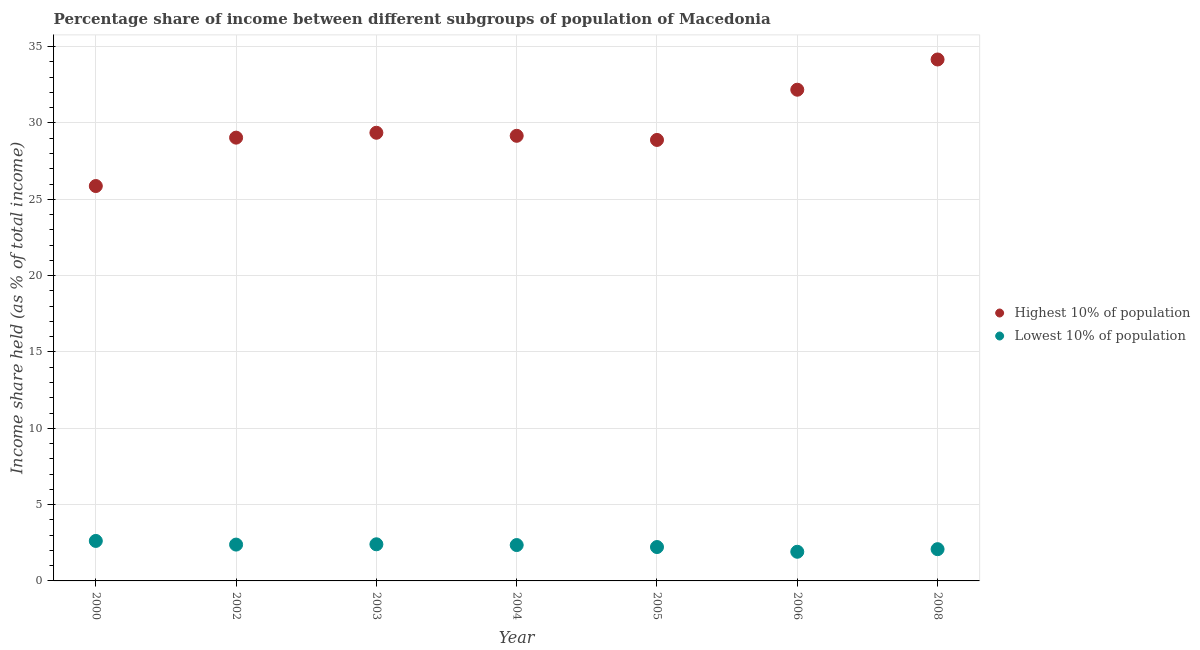How many different coloured dotlines are there?
Give a very brief answer. 2. What is the income share held by lowest 10% of the population in 2000?
Your answer should be compact. 2.62. Across all years, what is the maximum income share held by highest 10% of the population?
Your response must be concise. 34.16. Across all years, what is the minimum income share held by highest 10% of the population?
Ensure brevity in your answer.  25.87. In which year was the income share held by lowest 10% of the population maximum?
Your answer should be very brief. 2000. In which year was the income share held by highest 10% of the population minimum?
Your answer should be compact. 2000. What is the total income share held by highest 10% of the population in the graph?
Provide a short and direct response. 208.66. What is the difference between the income share held by lowest 10% of the population in 2005 and that in 2008?
Ensure brevity in your answer.  0.14. What is the difference between the income share held by lowest 10% of the population in 2000 and the income share held by highest 10% of the population in 2004?
Your answer should be compact. -26.54. What is the average income share held by lowest 10% of the population per year?
Your response must be concise. 2.28. In the year 2000, what is the difference between the income share held by lowest 10% of the population and income share held by highest 10% of the population?
Ensure brevity in your answer.  -23.25. What is the ratio of the income share held by lowest 10% of the population in 2000 to that in 2008?
Your answer should be very brief. 1.26. Is the income share held by lowest 10% of the population in 2002 less than that in 2006?
Your answer should be very brief. No. What is the difference between the highest and the second highest income share held by highest 10% of the population?
Your answer should be very brief. 1.98. What is the difference between the highest and the lowest income share held by lowest 10% of the population?
Make the answer very short. 0.71. Does the income share held by highest 10% of the population monotonically increase over the years?
Provide a succinct answer. No. Is the income share held by lowest 10% of the population strictly greater than the income share held by highest 10% of the population over the years?
Ensure brevity in your answer.  No. How many dotlines are there?
Provide a succinct answer. 2. Does the graph contain any zero values?
Provide a short and direct response. No. Where does the legend appear in the graph?
Your answer should be very brief. Center right. How are the legend labels stacked?
Ensure brevity in your answer.  Vertical. What is the title of the graph?
Offer a terse response. Percentage share of income between different subgroups of population of Macedonia. What is the label or title of the Y-axis?
Provide a short and direct response. Income share held (as % of total income). What is the Income share held (as % of total income) of Highest 10% of population in 2000?
Keep it short and to the point. 25.87. What is the Income share held (as % of total income) of Lowest 10% of population in 2000?
Your answer should be very brief. 2.62. What is the Income share held (as % of total income) of Highest 10% of population in 2002?
Offer a terse response. 29.04. What is the Income share held (as % of total income) in Lowest 10% of population in 2002?
Ensure brevity in your answer.  2.38. What is the Income share held (as % of total income) in Highest 10% of population in 2003?
Provide a succinct answer. 29.36. What is the Income share held (as % of total income) of Lowest 10% of population in 2003?
Your response must be concise. 2.4. What is the Income share held (as % of total income) of Highest 10% of population in 2004?
Provide a short and direct response. 29.16. What is the Income share held (as % of total income) in Lowest 10% of population in 2004?
Your answer should be compact. 2.35. What is the Income share held (as % of total income) in Highest 10% of population in 2005?
Ensure brevity in your answer.  28.89. What is the Income share held (as % of total income) of Lowest 10% of population in 2005?
Offer a terse response. 2.22. What is the Income share held (as % of total income) in Highest 10% of population in 2006?
Your answer should be very brief. 32.18. What is the Income share held (as % of total income) of Lowest 10% of population in 2006?
Ensure brevity in your answer.  1.91. What is the Income share held (as % of total income) of Highest 10% of population in 2008?
Provide a succinct answer. 34.16. What is the Income share held (as % of total income) in Lowest 10% of population in 2008?
Your answer should be compact. 2.08. Across all years, what is the maximum Income share held (as % of total income) of Highest 10% of population?
Provide a succinct answer. 34.16. Across all years, what is the maximum Income share held (as % of total income) of Lowest 10% of population?
Your answer should be compact. 2.62. Across all years, what is the minimum Income share held (as % of total income) in Highest 10% of population?
Your answer should be very brief. 25.87. Across all years, what is the minimum Income share held (as % of total income) of Lowest 10% of population?
Ensure brevity in your answer.  1.91. What is the total Income share held (as % of total income) of Highest 10% of population in the graph?
Give a very brief answer. 208.66. What is the total Income share held (as % of total income) in Lowest 10% of population in the graph?
Offer a very short reply. 15.96. What is the difference between the Income share held (as % of total income) in Highest 10% of population in 2000 and that in 2002?
Your answer should be compact. -3.17. What is the difference between the Income share held (as % of total income) in Lowest 10% of population in 2000 and that in 2002?
Offer a terse response. 0.24. What is the difference between the Income share held (as % of total income) of Highest 10% of population in 2000 and that in 2003?
Provide a succinct answer. -3.49. What is the difference between the Income share held (as % of total income) in Lowest 10% of population in 2000 and that in 2003?
Make the answer very short. 0.22. What is the difference between the Income share held (as % of total income) in Highest 10% of population in 2000 and that in 2004?
Provide a succinct answer. -3.29. What is the difference between the Income share held (as % of total income) of Lowest 10% of population in 2000 and that in 2004?
Your answer should be compact. 0.27. What is the difference between the Income share held (as % of total income) in Highest 10% of population in 2000 and that in 2005?
Keep it short and to the point. -3.02. What is the difference between the Income share held (as % of total income) of Highest 10% of population in 2000 and that in 2006?
Provide a succinct answer. -6.31. What is the difference between the Income share held (as % of total income) of Lowest 10% of population in 2000 and that in 2006?
Offer a very short reply. 0.71. What is the difference between the Income share held (as % of total income) of Highest 10% of population in 2000 and that in 2008?
Your answer should be compact. -8.29. What is the difference between the Income share held (as % of total income) of Lowest 10% of population in 2000 and that in 2008?
Keep it short and to the point. 0.54. What is the difference between the Income share held (as % of total income) in Highest 10% of population in 2002 and that in 2003?
Give a very brief answer. -0.32. What is the difference between the Income share held (as % of total income) in Lowest 10% of population in 2002 and that in 2003?
Give a very brief answer. -0.02. What is the difference between the Income share held (as % of total income) in Highest 10% of population in 2002 and that in 2004?
Provide a succinct answer. -0.12. What is the difference between the Income share held (as % of total income) in Lowest 10% of population in 2002 and that in 2004?
Your response must be concise. 0.03. What is the difference between the Income share held (as % of total income) of Lowest 10% of population in 2002 and that in 2005?
Your answer should be compact. 0.16. What is the difference between the Income share held (as % of total income) of Highest 10% of population in 2002 and that in 2006?
Keep it short and to the point. -3.14. What is the difference between the Income share held (as % of total income) of Lowest 10% of population in 2002 and that in 2006?
Your answer should be very brief. 0.47. What is the difference between the Income share held (as % of total income) in Highest 10% of population in 2002 and that in 2008?
Make the answer very short. -5.12. What is the difference between the Income share held (as % of total income) of Lowest 10% of population in 2003 and that in 2004?
Your answer should be compact. 0.05. What is the difference between the Income share held (as % of total income) of Highest 10% of population in 2003 and that in 2005?
Provide a short and direct response. 0.47. What is the difference between the Income share held (as % of total income) of Lowest 10% of population in 2003 and that in 2005?
Give a very brief answer. 0.18. What is the difference between the Income share held (as % of total income) in Highest 10% of population in 2003 and that in 2006?
Provide a succinct answer. -2.82. What is the difference between the Income share held (as % of total income) in Lowest 10% of population in 2003 and that in 2006?
Keep it short and to the point. 0.49. What is the difference between the Income share held (as % of total income) in Highest 10% of population in 2003 and that in 2008?
Your response must be concise. -4.8. What is the difference between the Income share held (as % of total income) in Lowest 10% of population in 2003 and that in 2008?
Make the answer very short. 0.32. What is the difference between the Income share held (as % of total income) in Highest 10% of population in 2004 and that in 2005?
Offer a terse response. 0.27. What is the difference between the Income share held (as % of total income) in Lowest 10% of population in 2004 and that in 2005?
Give a very brief answer. 0.13. What is the difference between the Income share held (as % of total income) of Highest 10% of population in 2004 and that in 2006?
Ensure brevity in your answer.  -3.02. What is the difference between the Income share held (as % of total income) of Lowest 10% of population in 2004 and that in 2006?
Ensure brevity in your answer.  0.44. What is the difference between the Income share held (as % of total income) in Highest 10% of population in 2004 and that in 2008?
Give a very brief answer. -5. What is the difference between the Income share held (as % of total income) in Lowest 10% of population in 2004 and that in 2008?
Keep it short and to the point. 0.27. What is the difference between the Income share held (as % of total income) of Highest 10% of population in 2005 and that in 2006?
Your answer should be very brief. -3.29. What is the difference between the Income share held (as % of total income) in Lowest 10% of population in 2005 and that in 2006?
Make the answer very short. 0.31. What is the difference between the Income share held (as % of total income) in Highest 10% of population in 2005 and that in 2008?
Your answer should be very brief. -5.27. What is the difference between the Income share held (as % of total income) in Lowest 10% of population in 2005 and that in 2008?
Give a very brief answer. 0.14. What is the difference between the Income share held (as % of total income) of Highest 10% of population in 2006 and that in 2008?
Your answer should be compact. -1.98. What is the difference between the Income share held (as % of total income) of Lowest 10% of population in 2006 and that in 2008?
Offer a very short reply. -0.17. What is the difference between the Income share held (as % of total income) of Highest 10% of population in 2000 and the Income share held (as % of total income) of Lowest 10% of population in 2002?
Ensure brevity in your answer.  23.49. What is the difference between the Income share held (as % of total income) in Highest 10% of population in 2000 and the Income share held (as % of total income) in Lowest 10% of population in 2003?
Your response must be concise. 23.47. What is the difference between the Income share held (as % of total income) in Highest 10% of population in 2000 and the Income share held (as % of total income) in Lowest 10% of population in 2004?
Make the answer very short. 23.52. What is the difference between the Income share held (as % of total income) of Highest 10% of population in 2000 and the Income share held (as % of total income) of Lowest 10% of population in 2005?
Ensure brevity in your answer.  23.65. What is the difference between the Income share held (as % of total income) of Highest 10% of population in 2000 and the Income share held (as % of total income) of Lowest 10% of population in 2006?
Your answer should be very brief. 23.96. What is the difference between the Income share held (as % of total income) of Highest 10% of population in 2000 and the Income share held (as % of total income) of Lowest 10% of population in 2008?
Make the answer very short. 23.79. What is the difference between the Income share held (as % of total income) in Highest 10% of population in 2002 and the Income share held (as % of total income) in Lowest 10% of population in 2003?
Give a very brief answer. 26.64. What is the difference between the Income share held (as % of total income) in Highest 10% of population in 2002 and the Income share held (as % of total income) in Lowest 10% of population in 2004?
Keep it short and to the point. 26.69. What is the difference between the Income share held (as % of total income) of Highest 10% of population in 2002 and the Income share held (as % of total income) of Lowest 10% of population in 2005?
Provide a short and direct response. 26.82. What is the difference between the Income share held (as % of total income) of Highest 10% of population in 2002 and the Income share held (as % of total income) of Lowest 10% of population in 2006?
Offer a very short reply. 27.13. What is the difference between the Income share held (as % of total income) of Highest 10% of population in 2002 and the Income share held (as % of total income) of Lowest 10% of population in 2008?
Provide a short and direct response. 26.96. What is the difference between the Income share held (as % of total income) in Highest 10% of population in 2003 and the Income share held (as % of total income) in Lowest 10% of population in 2004?
Keep it short and to the point. 27.01. What is the difference between the Income share held (as % of total income) of Highest 10% of population in 2003 and the Income share held (as % of total income) of Lowest 10% of population in 2005?
Your answer should be very brief. 27.14. What is the difference between the Income share held (as % of total income) of Highest 10% of population in 2003 and the Income share held (as % of total income) of Lowest 10% of population in 2006?
Your answer should be compact. 27.45. What is the difference between the Income share held (as % of total income) in Highest 10% of population in 2003 and the Income share held (as % of total income) in Lowest 10% of population in 2008?
Offer a very short reply. 27.28. What is the difference between the Income share held (as % of total income) of Highest 10% of population in 2004 and the Income share held (as % of total income) of Lowest 10% of population in 2005?
Make the answer very short. 26.94. What is the difference between the Income share held (as % of total income) of Highest 10% of population in 2004 and the Income share held (as % of total income) of Lowest 10% of population in 2006?
Your answer should be compact. 27.25. What is the difference between the Income share held (as % of total income) of Highest 10% of population in 2004 and the Income share held (as % of total income) of Lowest 10% of population in 2008?
Provide a short and direct response. 27.08. What is the difference between the Income share held (as % of total income) in Highest 10% of population in 2005 and the Income share held (as % of total income) in Lowest 10% of population in 2006?
Keep it short and to the point. 26.98. What is the difference between the Income share held (as % of total income) of Highest 10% of population in 2005 and the Income share held (as % of total income) of Lowest 10% of population in 2008?
Offer a terse response. 26.81. What is the difference between the Income share held (as % of total income) of Highest 10% of population in 2006 and the Income share held (as % of total income) of Lowest 10% of population in 2008?
Give a very brief answer. 30.1. What is the average Income share held (as % of total income) in Highest 10% of population per year?
Provide a succinct answer. 29.81. What is the average Income share held (as % of total income) in Lowest 10% of population per year?
Provide a succinct answer. 2.28. In the year 2000, what is the difference between the Income share held (as % of total income) of Highest 10% of population and Income share held (as % of total income) of Lowest 10% of population?
Your answer should be compact. 23.25. In the year 2002, what is the difference between the Income share held (as % of total income) in Highest 10% of population and Income share held (as % of total income) in Lowest 10% of population?
Offer a terse response. 26.66. In the year 2003, what is the difference between the Income share held (as % of total income) in Highest 10% of population and Income share held (as % of total income) in Lowest 10% of population?
Your response must be concise. 26.96. In the year 2004, what is the difference between the Income share held (as % of total income) of Highest 10% of population and Income share held (as % of total income) of Lowest 10% of population?
Your answer should be compact. 26.81. In the year 2005, what is the difference between the Income share held (as % of total income) in Highest 10% of population and Income share held (as % of total income) in Lowest 10% of population?
Provide a short and direct response. 26.67. In the year 2006, what is the difference between the Income share held (as % of total income) in Highest 10% of population and Income share held (as % of total income) in Lowest 10% of population?
Offer a terse response. 30.27. In the year 2008, what is the difference between the Income share held (as % of total income) in Highest 10% of population and Income share held (as % of total income) in Lowest 10% of population?
Your answer should be very brief. 32.08. What is the ratio of the Income share held (as % of total income) in Highest 10% of population in 2000 to that in 2002?
Offer a very short reply. 0.89. What is the ratio of the Income share held (as % of total income) in Lowest 10% of population in 2000 to that in 2002?
Provide a short and direct response. 1.1. What is the ratio of the Income share held (as % of total income) in Highest 10% of population in 2000 to that in 2003?
Provide a short and direct response. 0.88. What is the ratio of the Income share held (as % of total income) of Lowest 10% of population in 2000 to that in 2003?
Your answer should be very brief. 1.09. What is the ratio of the Income share held (as % of total income) in Highest 10% of population in 2000 to that in 2004?
Offer a terse response. 0.89. What is the ratio of the Income share held (as % of total income) of Lowest 10% of population in 2000 to that in 2004?
Offer a very short reply. 1.11. What is the ratio of the Income share held (as % of total income) in Highest 10% of population in 2000 to that in 2005?
Keep it short and to the point. 0.9. What is the ratio of the Income share held (as % of total income) in Lowest 10% of population in 2000 to that in 2005?
Ensure brevity in your answer.  1.18. What is the ratio of the Income share held (as % of total income) in Highest 10% of population in 2000 to that in 2006?
Ensure brevity in your answer.  0.8. What is the ratio of the Income share held (as % of total income) of Lowest 10% of population in 2000 to that in 2006?
Ensure brevity in your answer.  1.37. What is the ratio of the Income share held (as % of total income) of Highest 10% of population in 2000 to that in 2008?
Your answer should be compact. 0.76. What is the ratio of the Income share held (as % of total income) in Lowest 10% of population in 2000 to that in 2008?
Offer a very short reply. 1.26. What is the ratio of the Income share held (as % of total income) of Lowest 10% of population in 2002 to that in 2004?
Keep it short and to the point. 1.01. What is the ratio of the Income share held (as % of total income) of Highest 10% of population in 2002 to that in 2005?
Your response must be concise. 1.01. What is the ratio of the Income share held (as % of total income) in Lowest 10% of population in 2002 to that in 2005?
Keep it short and to the point. 1.07. What is the ratio of the Income share held (as % of total income) in Highest 10% of population in 2002 to that in 2006?
Your response must be concise. 0.9. What is the ratio of the Income share held (as % of total income) of Lowest 10% of population in 2002 to that in 2006?
Provide a succinct answer. 1.25. What is the ratio of the Income share held (as % of total income) of Highest 10% of population in 2002 to that in 2008?
Ensure brevity in your answer.  0.85. What is the ratio of the Income share held (as % of total income) in Lowest 10% of population in 2002 to that in 2008?
Provide a short and direct response. 1.14. What is the ratio of the Income share held (as % of total income) of Highest 10% of population in 2003 to that in 2004?
Give a very brief answer. 1.01. What is the ratio of the Income share held (as % of total income) of Lowest 10% of population in 2003 to that in 2004?
Your response must be concise. 1.02. What is the ratio of the Income share held (as % of total income) in Highest 10% of population in 2003 to that in 2005?
Make the answer very short. 1.02. What is the ratio of the Income share held (as % of total income) in Lowest 10% of population in 2003 to that in 2005?
Keep it short and to the point. 1.08. What is the ratio of the Income share held (as % of total income) in Highest 10% of population in 2003 to that in 2006?
Give a very brief answer. 0.91. What is the ratio of the Income share held (as % of total income) of Lowest 10% of population in 2003 to that in 2006?
Your answer should be very brief. 1.26. What is the ratio of the Income share held (as % of total income) in Highest 10% of population in 2003 to that in 2008?
Provide a short and direct response. 0.86. What is the ratio of the Income share held (as % of total income) of Lowest 10% of population in 2003 to that in 2008?
Offer a terse response. 1.15. What is the ratio of the Income share held (as % of total income) of Highest 10% of population in 2004 to that in 2005?
Keep it short and to the point. 1.01. What is the ratio of the Income share held (as % of total income) in Lowest 10% of population in 2004 to that in 2005?
Your answer should be compact. 1.06. What is the ratio of the Income share held (as % of total income) in Highest 10% of population in 2004 to that in 2006?
Make the answer very short. 0.91. What is the ratio of the Income share held (as % of total income) in Lowest 10% of population in 2004 to that in 2006?
Give a very brief answer. 1.23. What is the ratio of the Income share held (as % of total income) of Highest 10% of population in 2004 to that in 2008?
Offer a terse response. 0.85. What is the ratio of the Income share held (as % of total income) in Lowest 10% of population in 2004 to that in 2008?
Offer a very short reply. 1.13. What is the ratio of the Income share held (as % of total income) of Highest 10% of population in 2005 to that in 2006?
Offer a very short reply. 0.9. What is the ratio of the Income share held (as % of total income) of Lowest 10% of population in 2005 to that in 2006?
Ensure brevity in your answer.  1.16. What is the ratio of the Income share held (as % of total income) of Highest 10% of population in 2005 to that in 2008?
Offer a terse response. 0.85. What is the ratio of the Income share held (as % of total income) in Lowest 10% of population in 2005 to that in 2008?
Keep it short and to the point. 1.07. What is the ratio of the Income share held (as % of total income) in Highest 10% of population in 2006 to that in 2008?
Provide a succinct answer. 0.94. What is the ratio of the Income share held (as % of total income) in Lowest 10% of population in 2006 to that in 2008?
Provide a succinct answer. 0.92. What is the difference between the highest and the second highest Income share held (as % of total income) in Highest 10% of population?
Keep it short and to the point. 1.98. What is the difference between the highest and the second highest Income share held (as % of total income) of Lowest 10% of population?
Provide a succinct answer. 0.22. What is the difference between the highest and the lowest Income share held (as % of total income) in Highest 10% of population?
Provide a succinct answer. 8.29. What is the difference between the highest and the lowest Income share held (as % of total income) in Lowest 10% of population?
Offer a terse response. 0.71. 